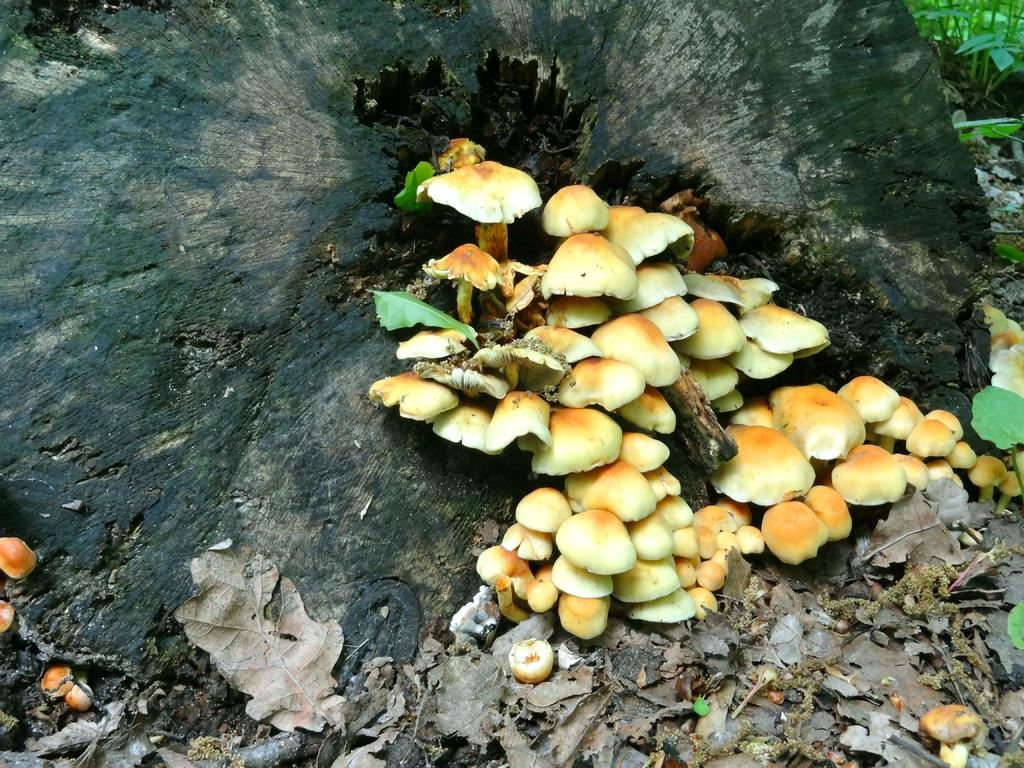What is the main subject of the image? The main subject of the image is a tree trunk. What other objects can be seen near the tree trunk? There are mushrooms and dried leaves present in the image. What can be seen in the background of the image? There are plants visible in the background of the image. How does the belief system of the mushrooms affect their growth in the image? There is no indication in the image that the mushrooms have a belief system, and therefore this cannot be determined. 